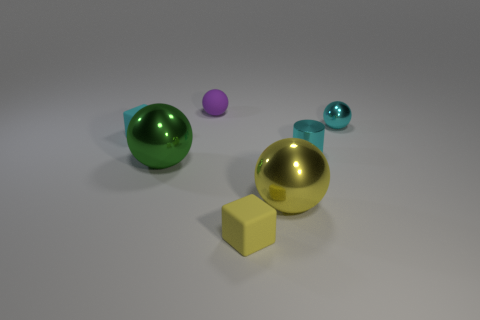There is a thing that is behind the tiny yellow object and in front of the big green shiny thing; what shape is it?
Your answer should be compact. Sphere. There is a tiny cylinder; does it have the same color as the tiny block behind the yellow matte cube?
Your response must be concise. Yes. Do the cyan metallic object that is behind the cyan cube and the cyan cube have the same size?
Offer a terse response. Yes. There is a purple object that is the same shape as the green metallic object; what is it made of?
Ensure brevity in your answer.  Rubber. Do the tiny yellow matte object and the tiny cyan rubber thing have the same shape?
Your response must be concise. Yes. What number of cyan blocks are on the right side of the large ball that is behind the yellow shiny ball?
Offer a very short reply. 0. What shape is the large yellow thing that is made of the same material as the small cyan ball?
Provide a succinct answer. Sphere. What number of green objects are either small metal objects or matte balls?
Your response must be concise. 0. There is a tiny cyan metallic object that is in front of the small cyan metal object on the right side of the tiny cyan cylinder; are there any purple matte balls on the right side of it?
Keep it short and to the point. No. Are there fewer large purple shiny blocks than tiny cyan cubes?
Give a very brief answer. Yes. 